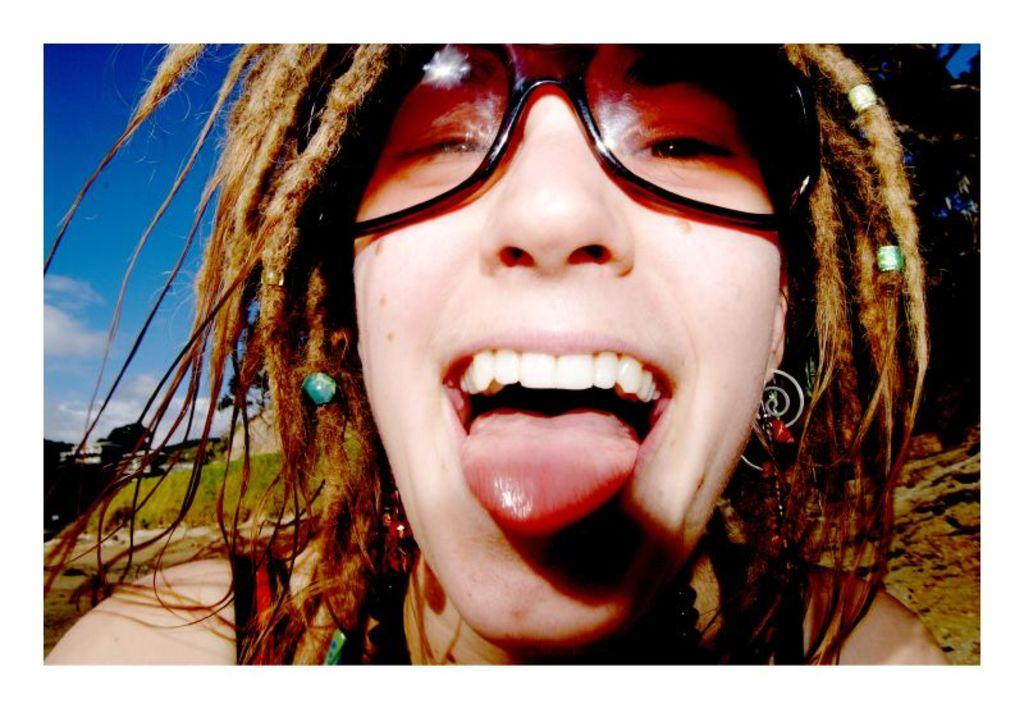What can be seen in the image? There is a person in the image, along with trees, a building, and the sky. Can you describe the person in the image? The person is wearing glasses. What type of natural environment is visible in the image? Trees can be seen in the image. What type of structure is present in the image? There is a building in the image. How would you describe the weather based on the image? The sky appears cloudy in the image. Reasoning: Let's think step by breaking down the facts to create the conversation. We start by identifying the main subject in the image, which is the person. Then, we expand the conversation to include other details about the person, such as their glasses. Next, we describe the natural and man-made elements in the image, including the trees, building, and sky. Finally, we use the information about the sky to infer the weather conditions in the image. Absurd Question/Answer: What type of cracker is the person holding in the image? There is no cracker present in the image. How does the sea affect the behavior of the person in the image? There is no sea visible in the image, and therefore it cannot affect the person's behavior. 